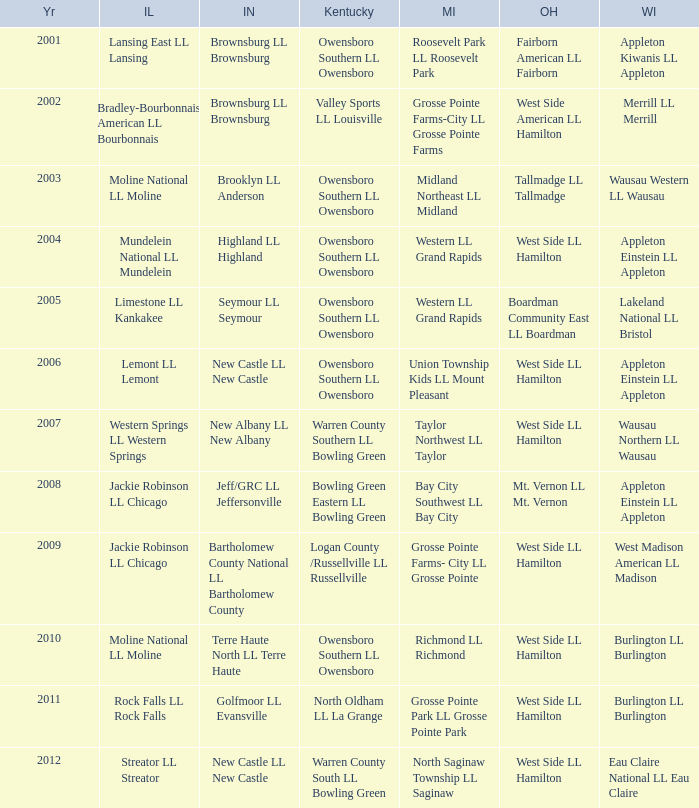What was the little league team from Kentucky when the little league team from Michigan was Grosse Pointe Farms-City LL Grosse Pointe Farms?  Valley Sports LL Louisville. 